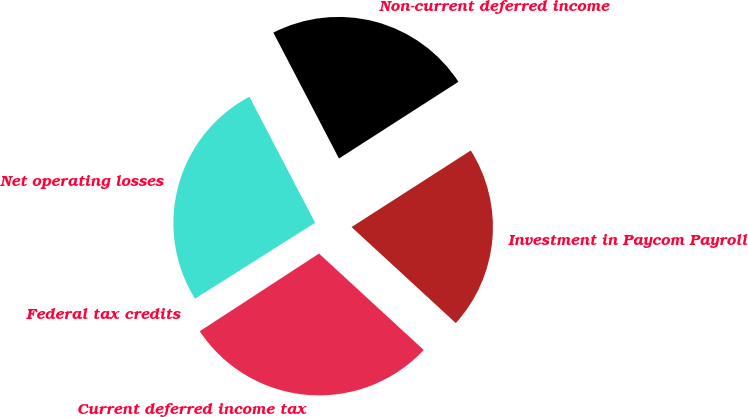Convert chart. <chart><loc_0><loc_0><loc_500><loc_500><pie_chart><fcel>Net operating losses<fcel>Federal tax credits<fcel>Current deferred income tax<fcel>Investment in Paycom Payroll<fcel>Non-current deferred income<nl><fcel>26.33%<fcel>0.21%<fcel>28.97%<fcel>20.93%<fcel>23.56%<nl></chart> 